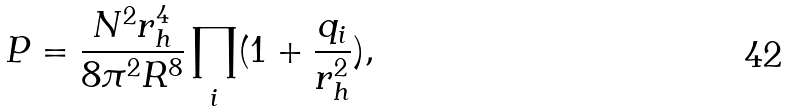Convert formula to latex. <formula><loc_0><loc_0><loc_500><loc_500>P = \frac { N ^ { 2 } r _ { h } ^ { 4 } } { 8 \pi ^ { 2 } R ^ { 8 } } \prod _ { i } ( 1 + \frac { q _ { i } } { r _ { h } ^ { 2 } } ) ,</formula> 